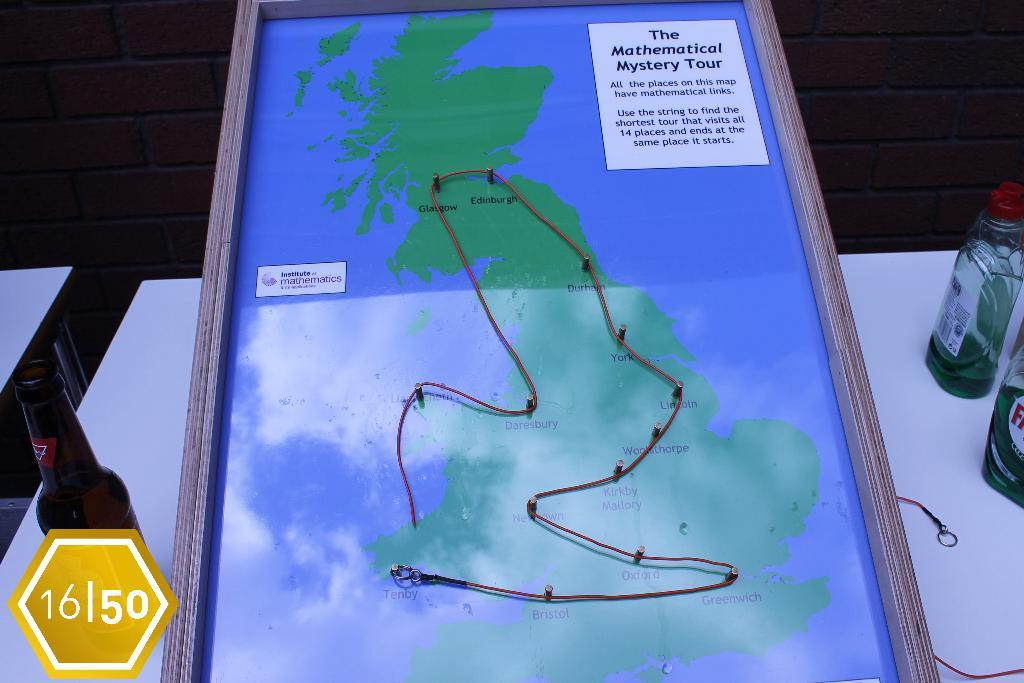<image>
Provide a brief description of the given image. A map with a string on it called the Mathematical Mystery Tour 